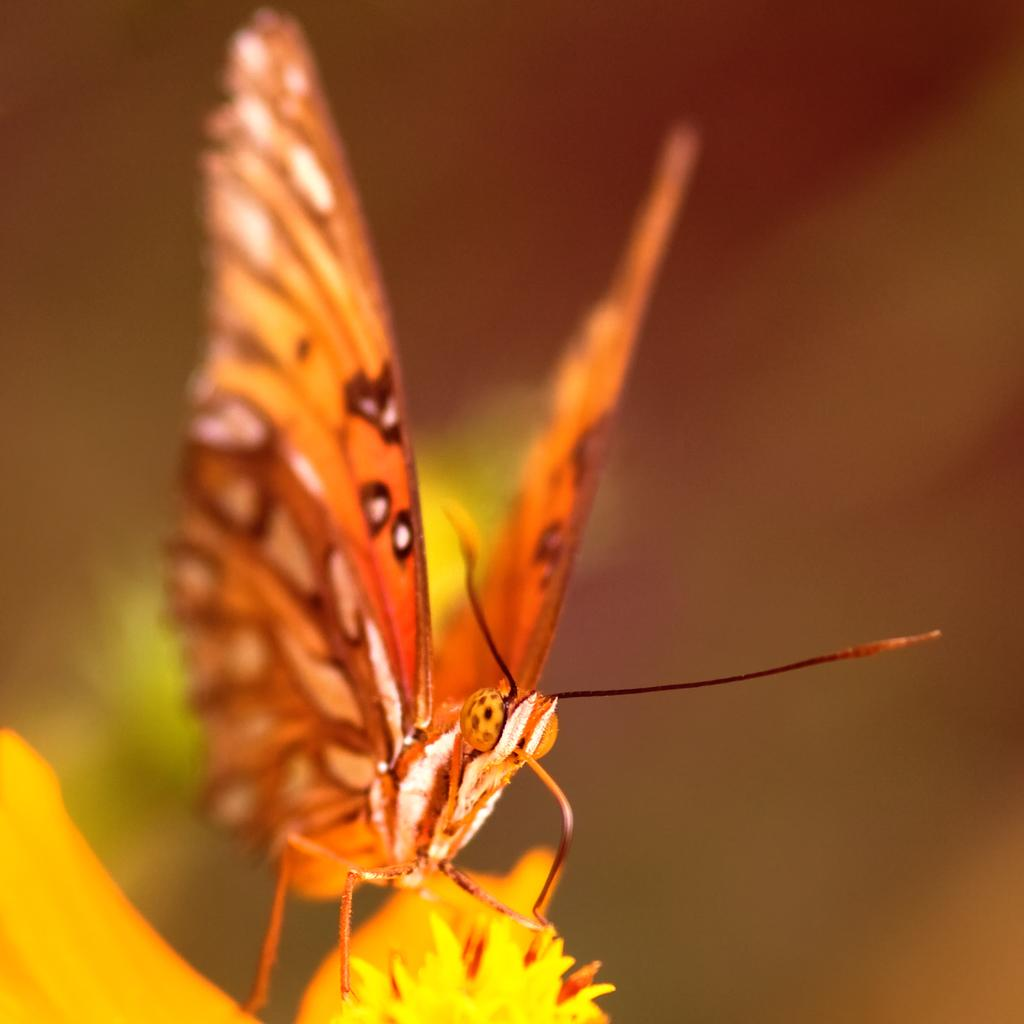What is the main subject of the image? The main subject of the image is a butterfly. Where is the butterfly located in the image? The butterfly is on a flower. Can you describe the background of the image? The background of the image is blurred. What grade of steel can be seen in the image? There is no steel present in the image; it features a butterfly on a flower with a blurred background. 